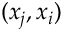Convert formula to latex. <formula><loc_0><loc_0><loc_500><loc_500>( x _ { j } , x _ { i } )</formula> 